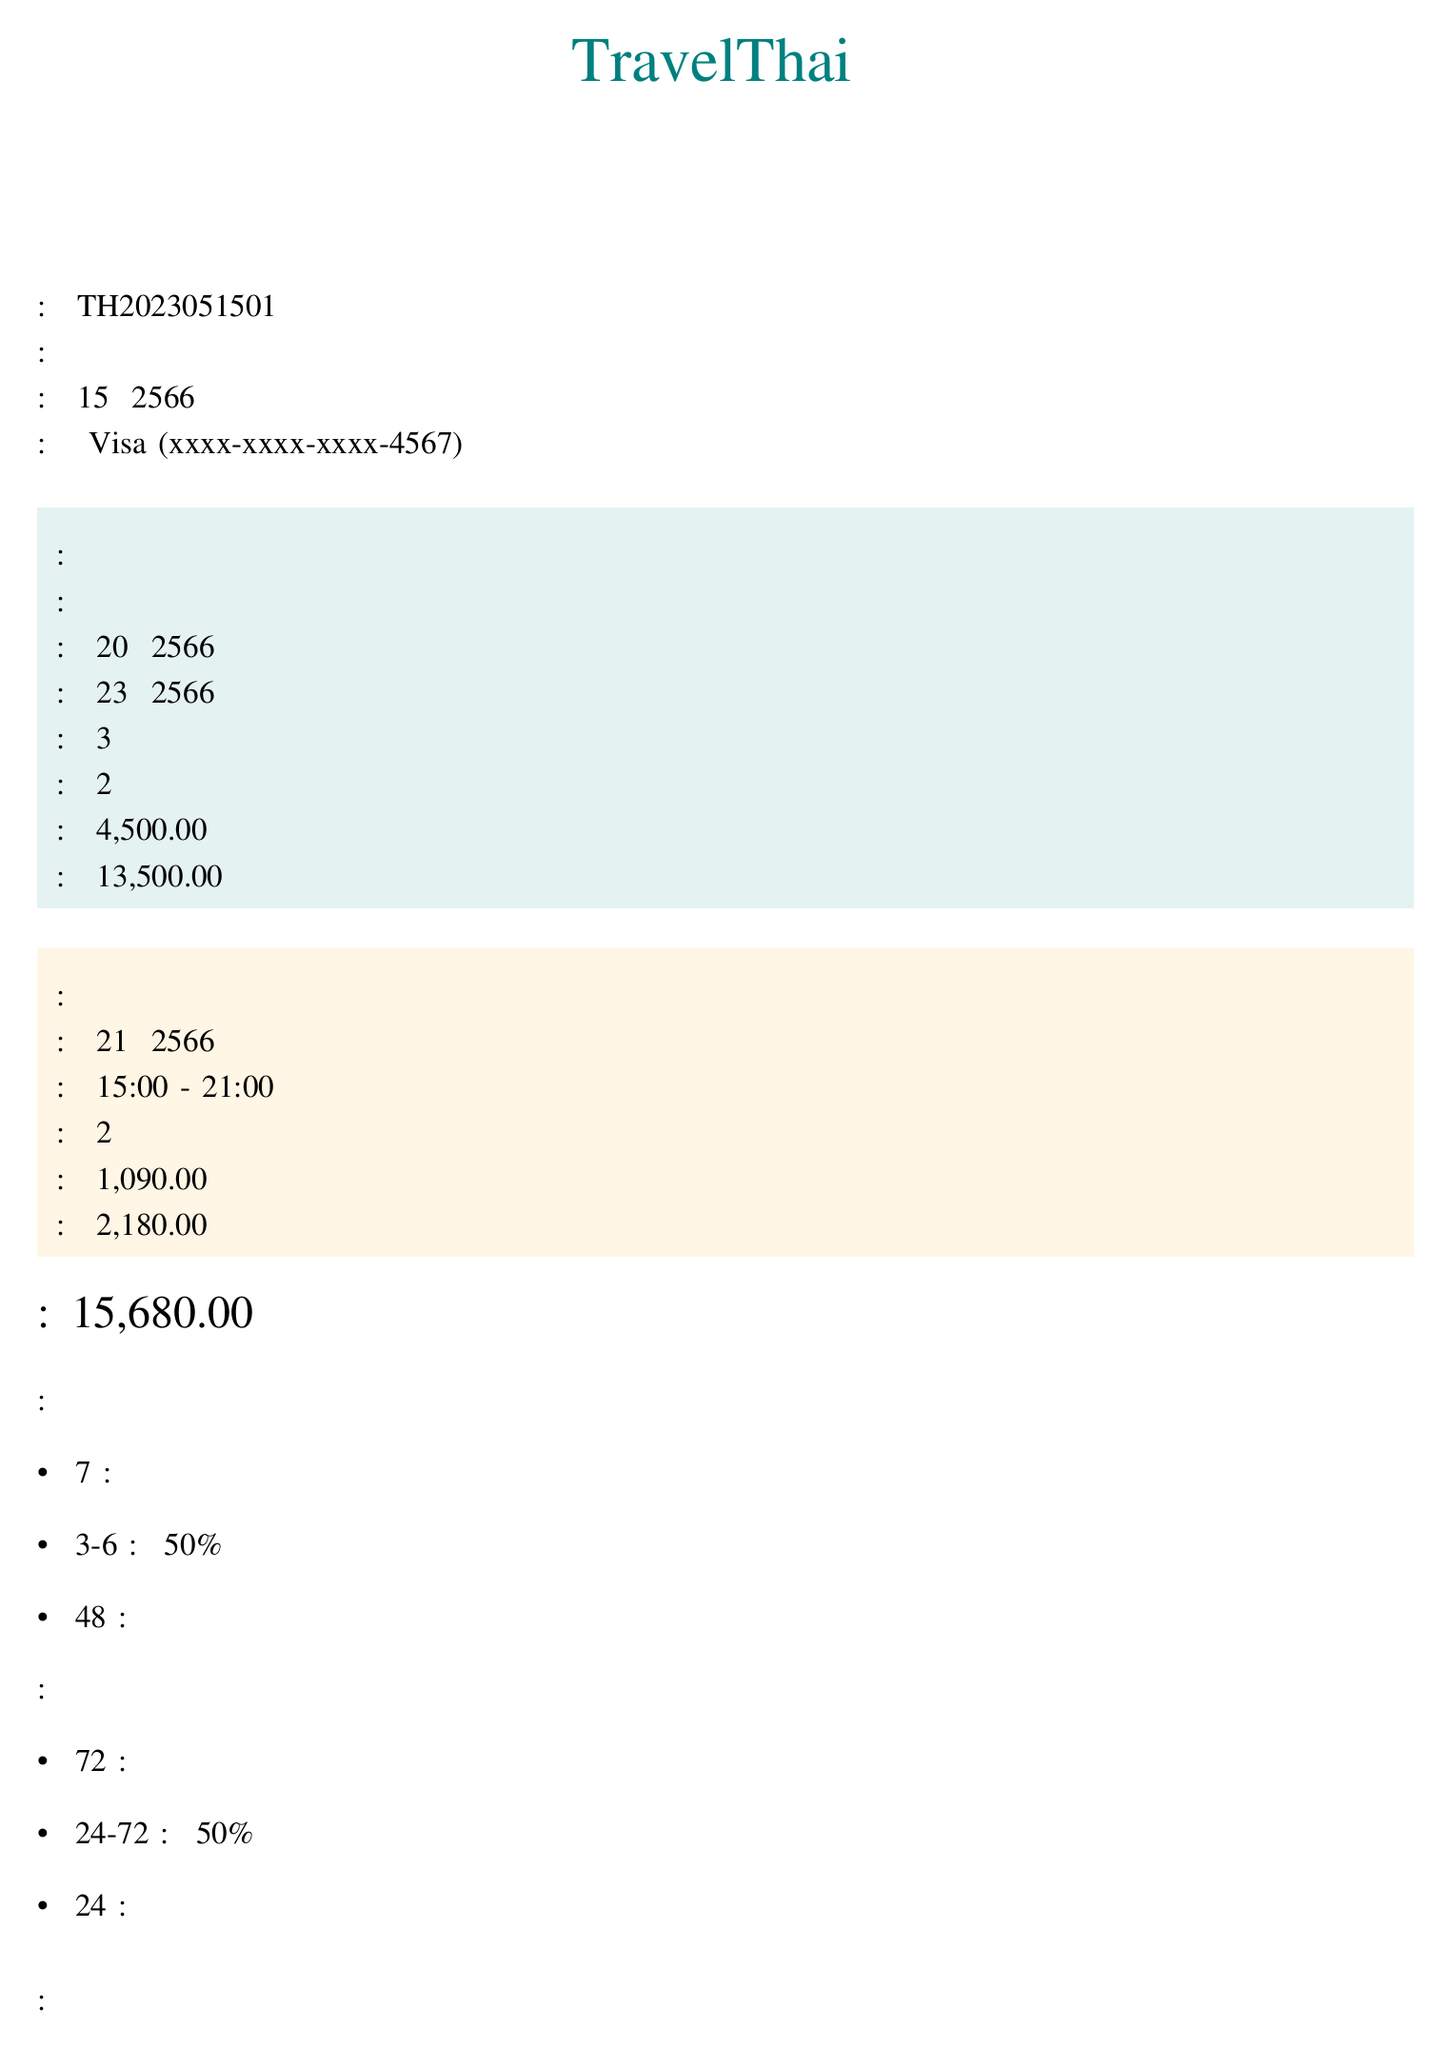หมายเลขการจองคืออะไร? หมายเลขการจองเป็นหมายเลขระบุตัวตนสำหรับการจองนั้น ในเอกสารแสดงว่าเป็น TH2023051501
Answer: TH2023051501 ชื่อลูกค้าเป็นใคร? ชื่อลูกค้าแสดงอยู่ในเอกสารว่า "คุณสมชาย ใจดี"
Answer: คุณสมชาย ใจดี วันที่เช็คอินคือวันไหน? วันที่เช็คอินระบุในเอกสารว่าเป็นวันที่ 20 พฤษภาคม 2566
Answer: 20 พฤษภาคม 2566 ราคาต่อคืนของห้องพักเท่าไหร่? ราคาต่อคืนของห้องพักที่ระบุในเอกสารคือ 4500.00 บาท
Answer: 4,500.00 บาท นโยบายการยกเลิกสำหรับโรงแรมคืออะไร? นโยบายการยกเลิกของโรงแรมมีหลายข้อ ในเอกสารระบุว่า "ยกเลิกก่อน 7 วันจากวันเช็คอิน: คืนเงินเต็มจำนวน"
Answer: ยกเลิกก่อน 7 วันจากวันเช็คอิน: คืนเงินเต็มจำนวน กิจกรรมท่องเที่ยวที่จองไว้คืออะไร? ในเอกสารบอกว่ากิจกรรมท่องเที่ยวที่จองไว้คือ "ทัวร์ตลาดน้ำอัมพวาและหิ่งห้อย"
Answer: ทัวร์ตลาดน้ำอัมพวาและหิ่งห้อย จำนวนคืนที่จองโรงแรมคือกี่คืน? จำนวนคืนที่ระบุในเอกสารคือ 3 คืน
Answer: 3 วิธีการชำระเงินคืออะไร? เอกสารระบุว่าวิธีการชำระเงินคือ "บัตรเครดิต Visa"
Answer: บัตรเครดิต Visa ราคาทั้งหมดที่จ่ายคือเท่าไหร่? ราคาทั้งหมดระบุในเอกสารว่าเป็น 15,680.00 บาท
Answer: 15,680.00 บาท 